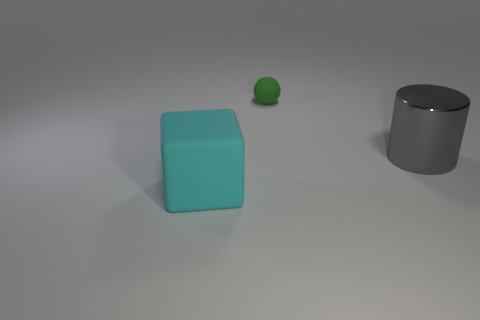What is the relative size of the green sphere to the other objects? The green sphere is significantly smaller than the other two objects, the cyan cube, and the gray cylinder. Its diminutive size provides a sense of scale and proportion within the image, showcasing the contrasting dimensions of the objects present. 